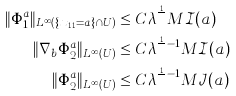Convert formula to latex. <formula><loc_0><loc_0><loc_500><loc_500>\| \Phi _ { 1 } ^ { a } \| _ { L ^ { \infty } ( \{ x _ { 1 1 } = a \} \cap U ) } & \leq C \lambda ^ { \frac { 1 } { Q } } M \mathcal { I } ( a ) \\ \| \nabla _ { b } \Phi _ { 2 } ^ { a } \| _ { L ^ { \infty } ( U ) } & \leq C \lambda ^ { \frac { 1 } { Q } - 1 } M \mathcal { I } ( a ) \\ \| \Phi _ { 2 } ^ { a } \| _ { L ^ { \infty } ( U ) } & \leq C \lambda ^ { \frac { 1 } { Q } - 1 } M \mathcal { J } ( a )</formula> 